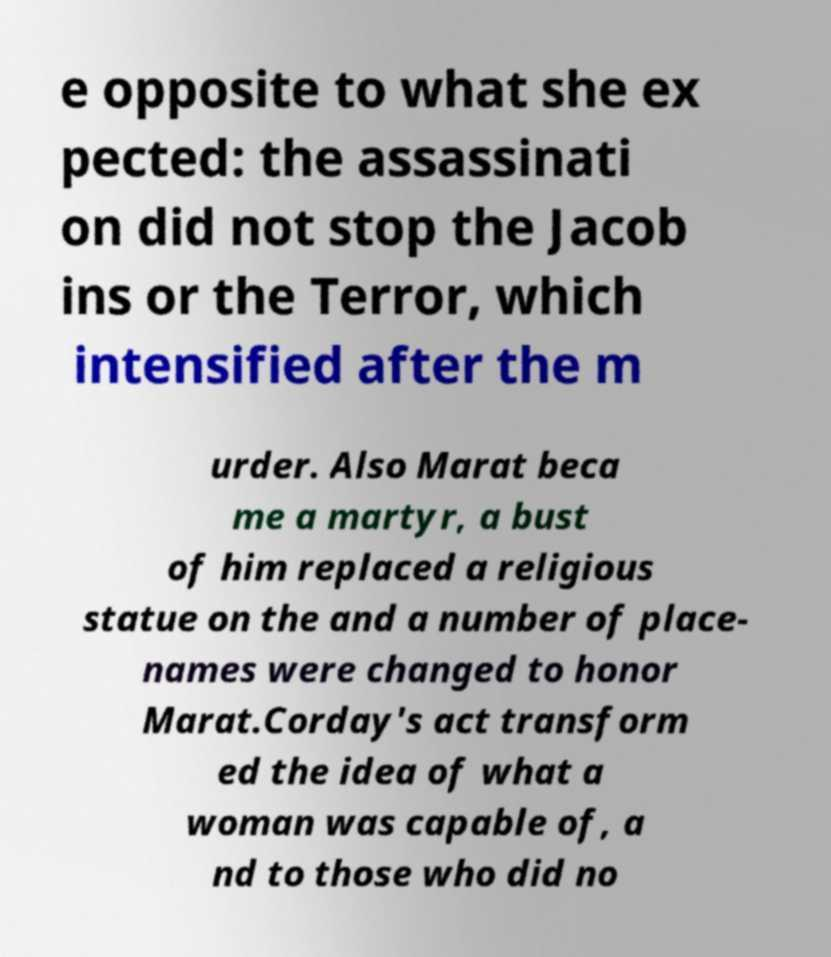I need the written content from this picture converted into text. Can you do that? e opposite to what she ex pected: the assassinati on did not stop the Jacob ins or the Terror, which intensified after the m urder. Also Marat beca me a martyr, a bust of him replaced a religious statue on the and a number of place- names were changed to honor Marat.Corday's act transform ed the idea of what a woman was capable of, a nd to those who did no 